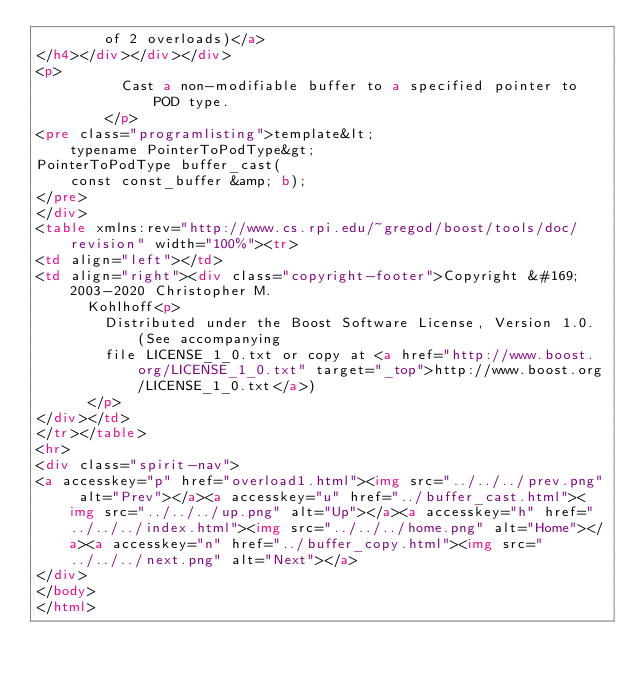Convert code to text. <code><loc_0><loc_0><loc_500><loc_500><_HTML_>        of 2 overloads)</a>
</h4></div></div></div>
<p>
          Cast a non-modifiable buffer to a specified pointer to POD type.
        </p>
<pre class="programlisting">template&lt;
    typename PointerToPodType&gt;
PointerToPodType buffer_cast(
    const const_buffer &amp; b);
</pre>
</div>
<table xmlns:rev="http://www.cs.rpi.edu/~gregod/boost/tools/doc/revision" width="100%"><tr>
<td align="left"></td>
<td align="right"><div class="copyright-footer">Copyright &#169; 2003-2020 Christopher M.
      Kohlhoff<p>
        Distributed under the Boost Software License, Version 1.0. (See accompanying
        file LICENSE_1_0.txt or copy at <a href="http://www.boost.org/LICENSE_1_0.txt" target="_top">http://www.boost.org/LICENSE_1_0.txt</a>)
      </p>
</div></td>
</tr></table>
<hr>
<div class="spirit-nav">
<a accesskey="p" href="overload1.html"><img src="../../../prev.png" alt="Prev"></a><a accesskey="u" href="../buffer_cast.html"><img src="../../../up.png" alt="Up"></a><a accesskey="h" href="../../../index.html"><img src="../../../home.png" alt="Home"></a><a accesskey="n" href="../buffer_copy.html"><img src="../../../next.png" alt="Next"></a>
</div>
</body>
</html>
</code> 